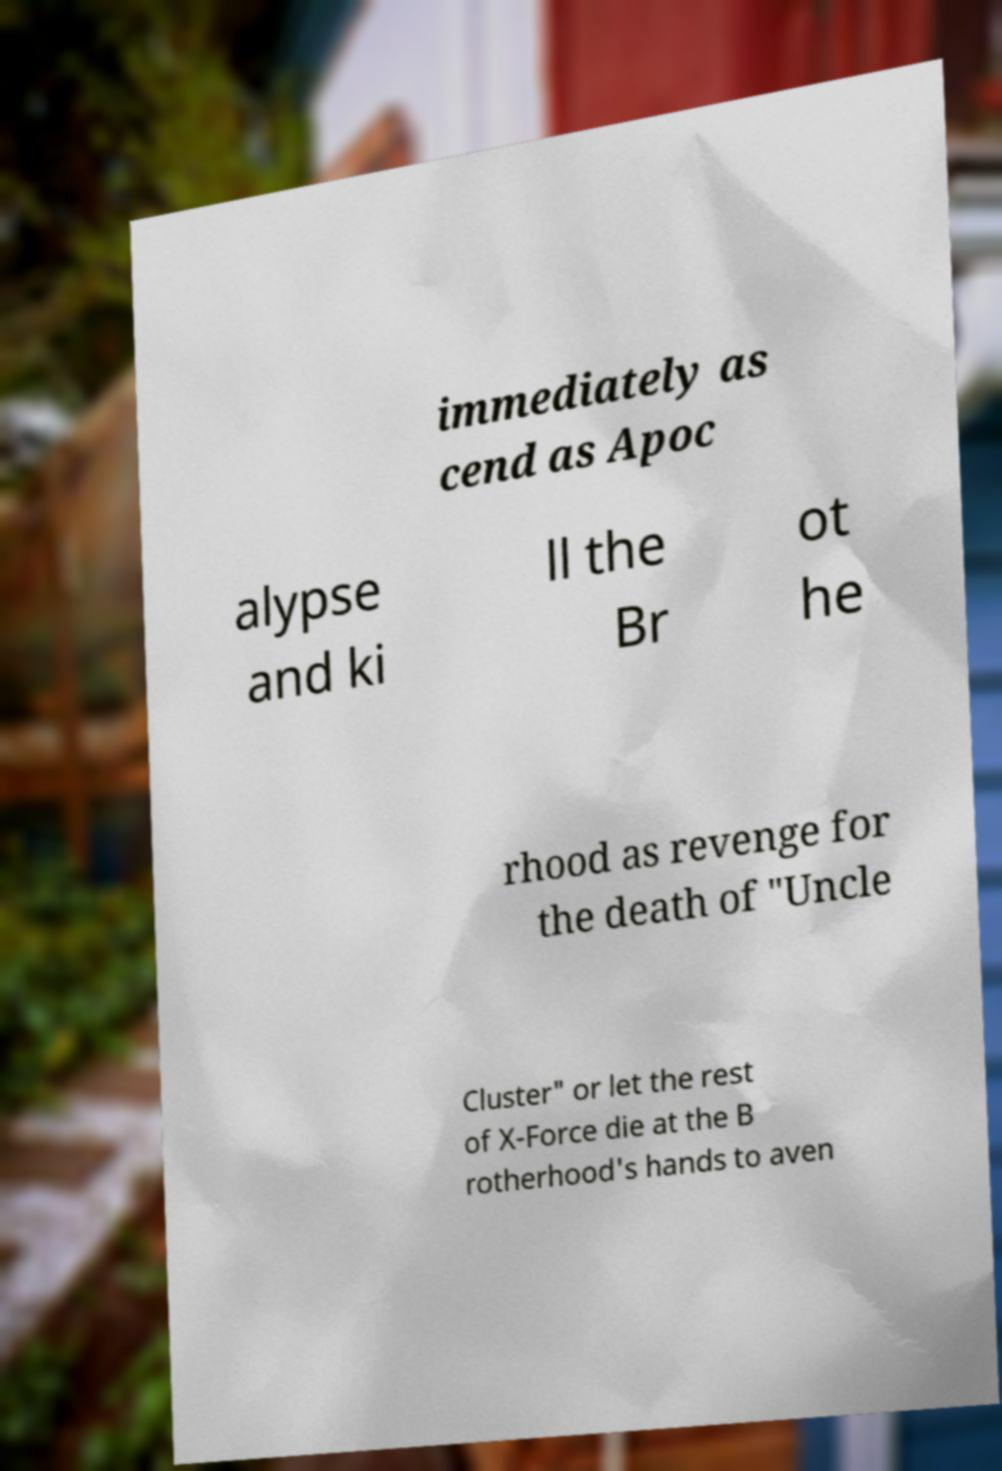For documentation purposes, I need the text within this image transcribed. Could you provide that? immediately as cend as Apoc alypse and ki ll the Br ot he rhood as revenge for the death of "Uncle Cluster" or let the rest of X-Force die at the B rotherhood's hands to aven 